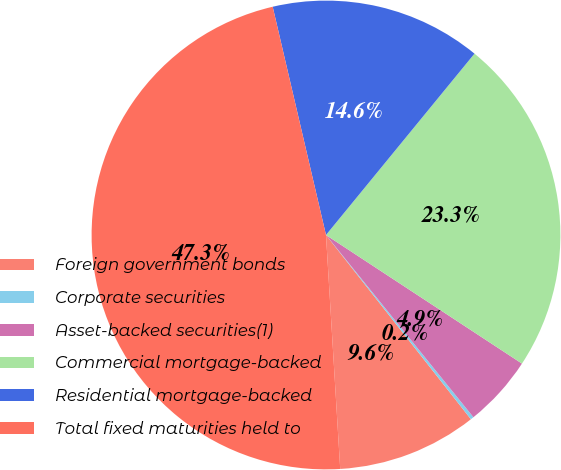Convert chart. <chart><loc_0><loc_0><loc_500><loc_500><pie_chart><fcel>Foreign government bonds<fcel>Corporate securities<fcel>Asset-backed securities(1)<fcel>Commercial mortgage-backed<fcel>Residential mortgage-backed<fcel>Total fixed maturities held to<nl><fcel>9.64%<fcel>0.22%<fcel>4.93%<fcel>23.32%<fcel>14.57%<fcel>47.31%<nl></chart> 